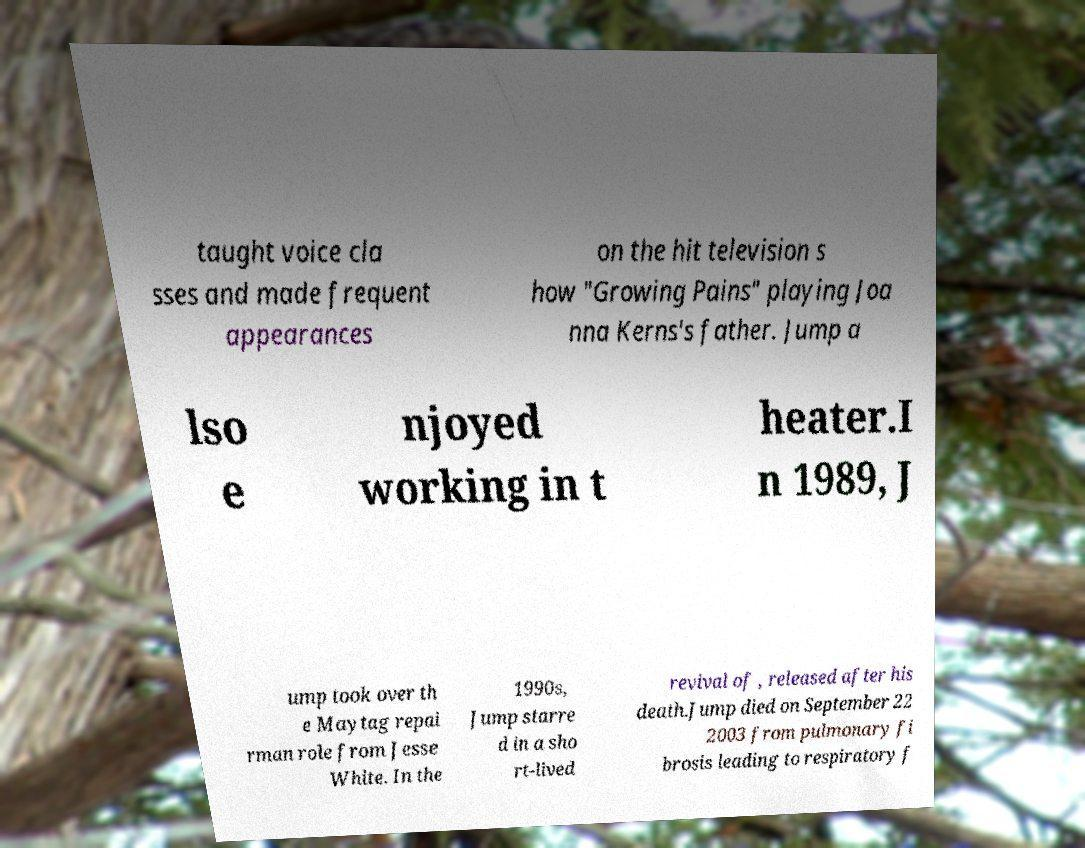Can you read and provide the text displayed in the image?This photo seems to have some interesting text. Can you extract and type it out for me? taught voice cla sses and made frequent appearances on the hit television s how "Growing Pains" playing Joa nna Kerns's father. Jump a lso e njoyed working in t heater.I n 1989, J ump took over th e Maytag repai rman role from Jesse White. In the 1990s, Jump starre d in a sho rt-lived revival of , released after his death.Jump died on September 22 2003 from pulmonary fi brosis leading to respiratory f 